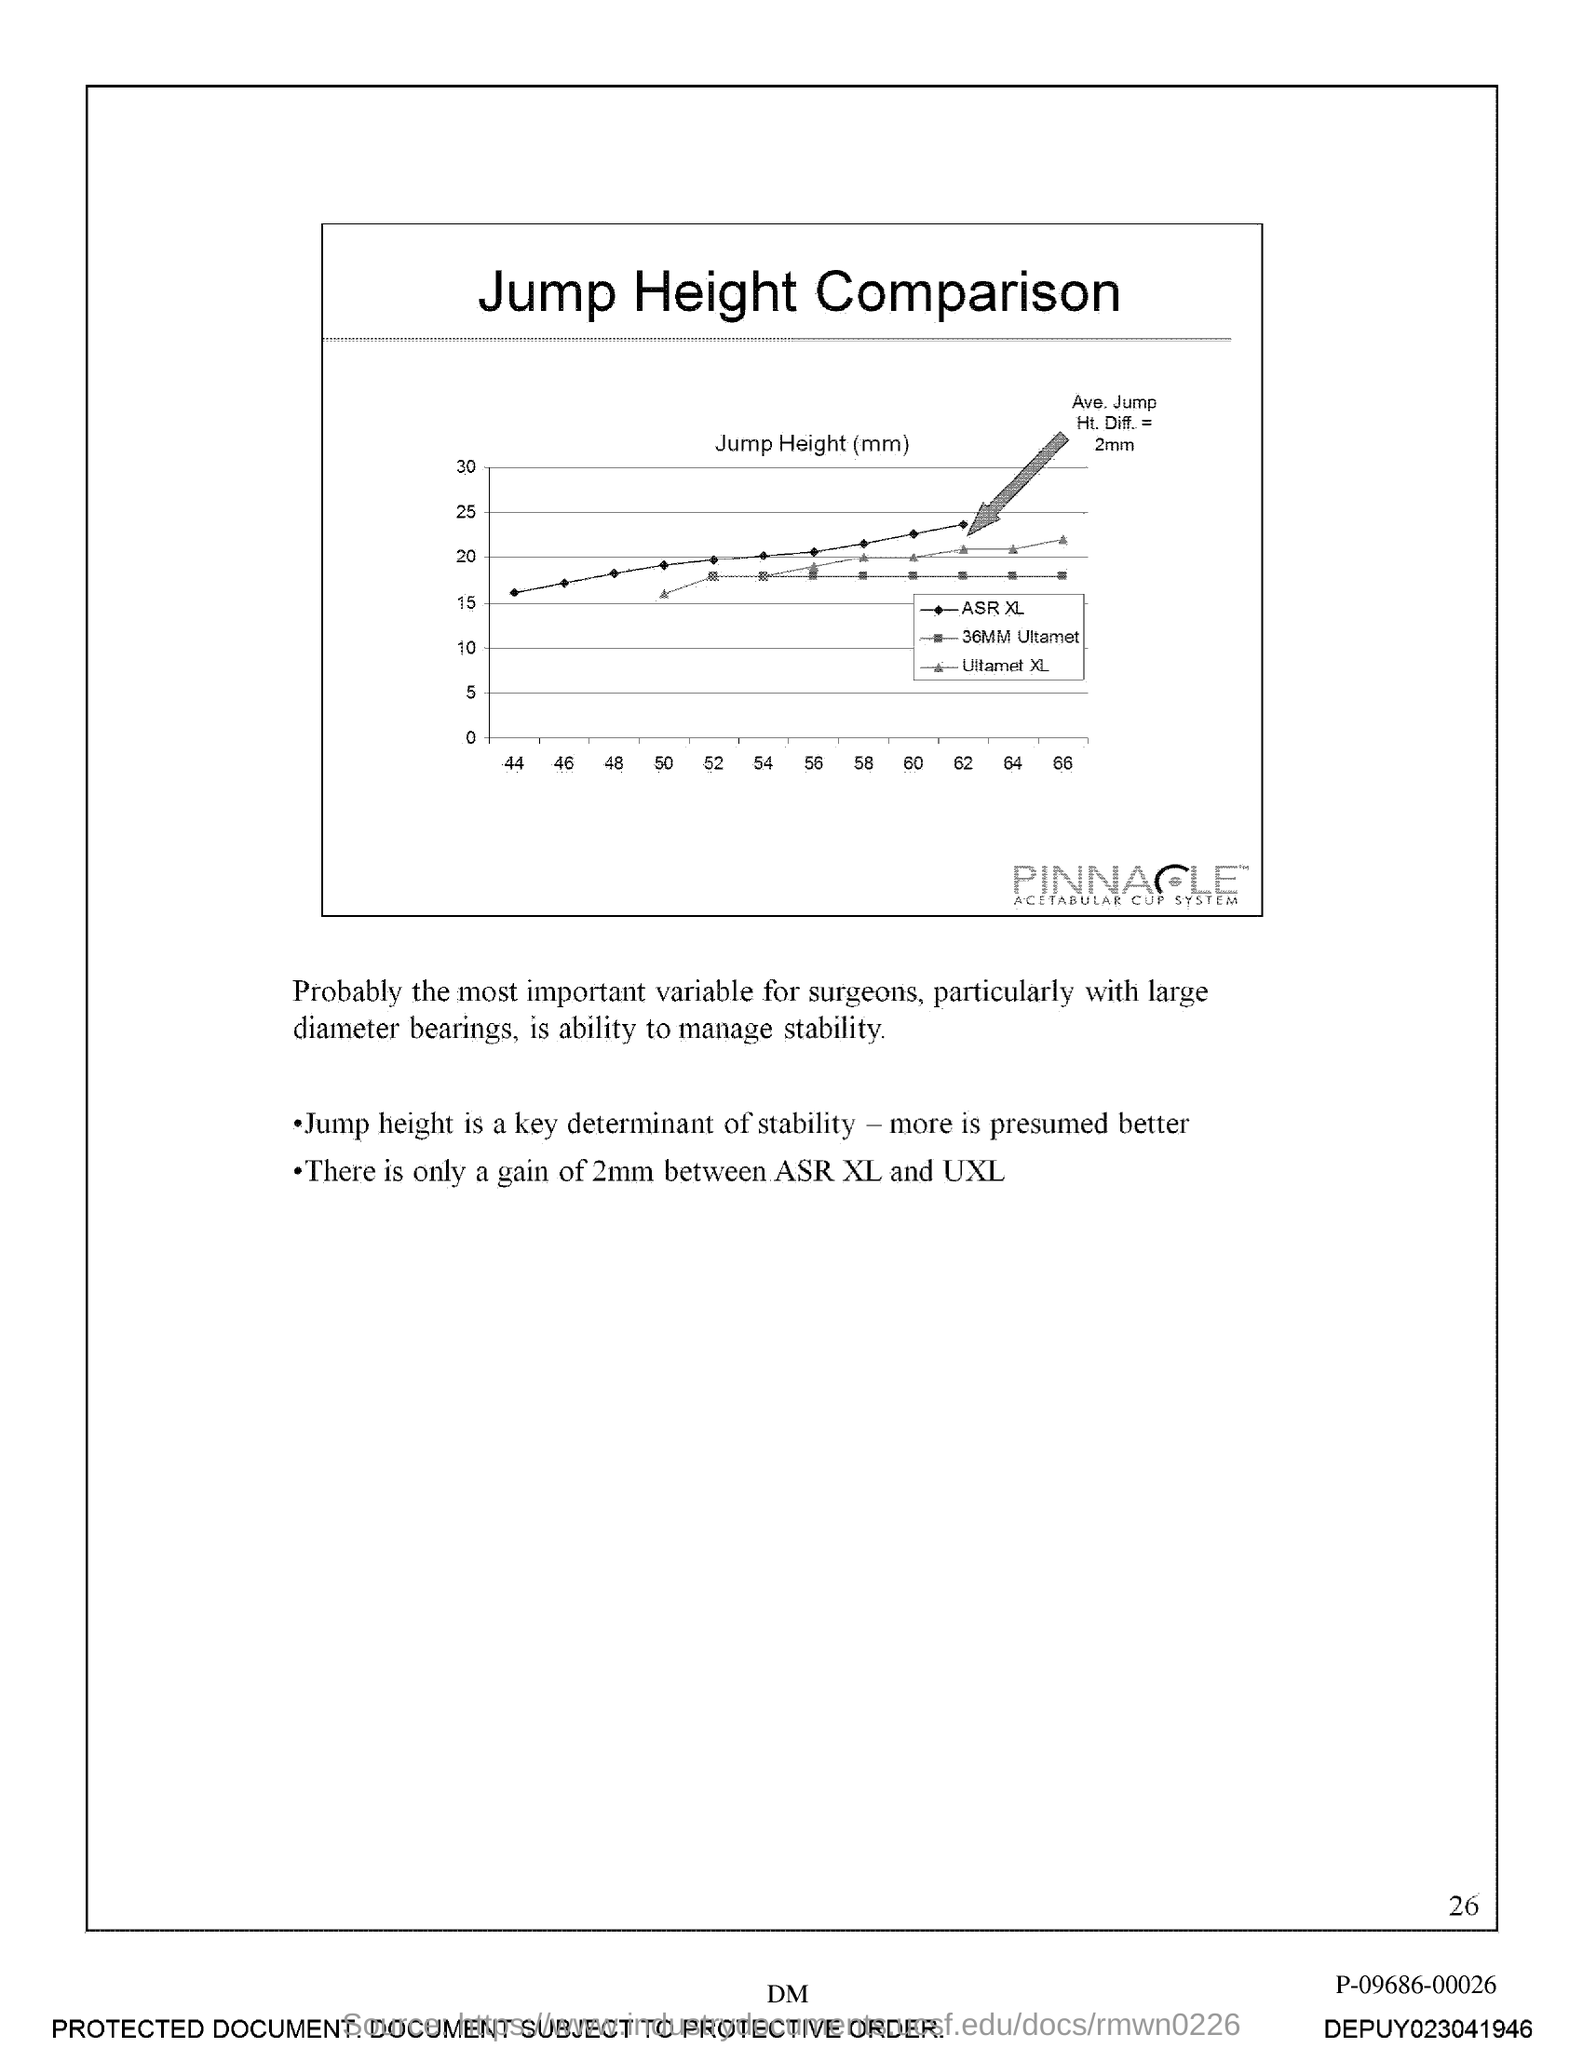Highlight a few significant elements in this photo. The document is titled "Jump Height Comparison. 